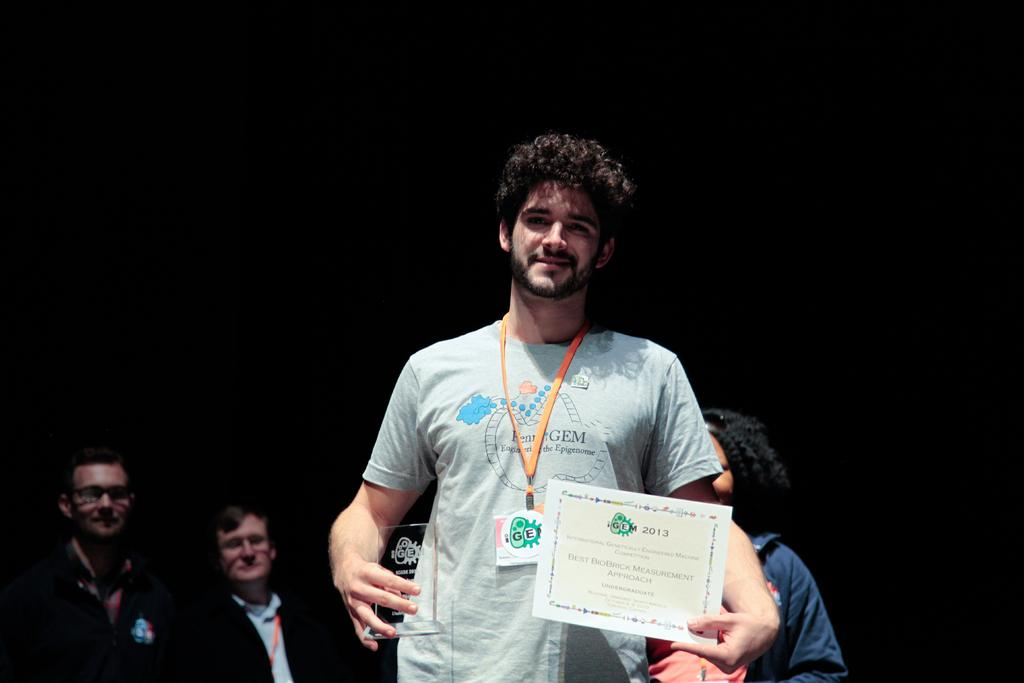What is the person in the image doing? The person is holding a shield and a card, watching, and smiling. What might the person be looking at in the image? The person might be looking at the people visible in the background. What is the color of the background in the image? The background in the image is dark. What is the person holding in their hand besides the shield? The person is holding a card in their hand. What type of stamp can be seen on the person's forehead in the image? There is no stamp visible on the person's forehead in the image. What type of poison is the person holding in their hand in the image? The person is not holding any poison in their hand; they are holding a shield and a card. 